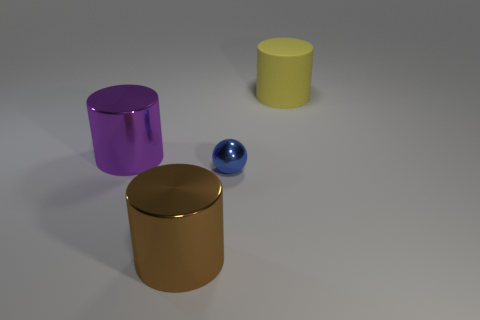What size is the metal cylinder on the right side of the thing to the left of the big shiny thing that is in front of the small blue shiny sphere? The metal cylinder on the right, which is situated to the left of the reflective gold cylinder in front of the small blue shiny sphere, is of a medium size relative to the other objects in the image. 